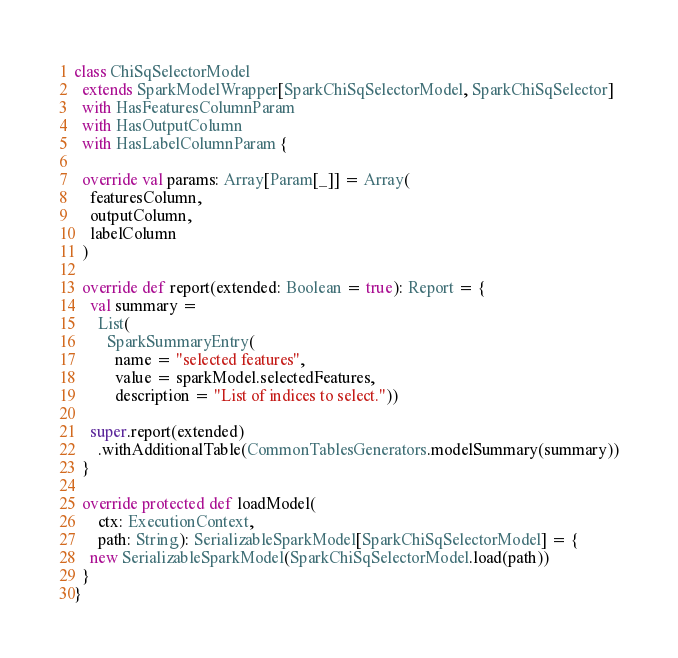Convert code to text. <code><loc_0><loc_0><loc_500><loc_500><_Scala_>class ChiSqSelectorModel
  extends SparkModelWrapper[SparkChiSqSelectorModel, SparkChiSqSelector]
  with HasFeaturesColumnParam
  with HasOutputColumn
  with HasLabelColumnParam {

  override val params: Array[Param[_]] = Array(
    featuresColumn,
    outputColumn,
    labelColumn
  )

  override def report(extended: Boolean = true): Report = {
    val summary =
      List(
        SparkSummaryEntry(
          name = "selected features",
          value = sparkModel.selectedFeatures,
          description = "List of indices to select."))

    super.report(extended)
      .withAdditionalTable(CommonTablesGenerators.modelSummary(summary))
  }

  override protected def loadModel(
      ctx: ExecutionContext,
      path: String): SerializableSparkModel[SparkChiSqSelectorModel] = {
    new SerializableSparkModel(SparkChiSqSelectorModel.load(path))
  }
}
</code> 